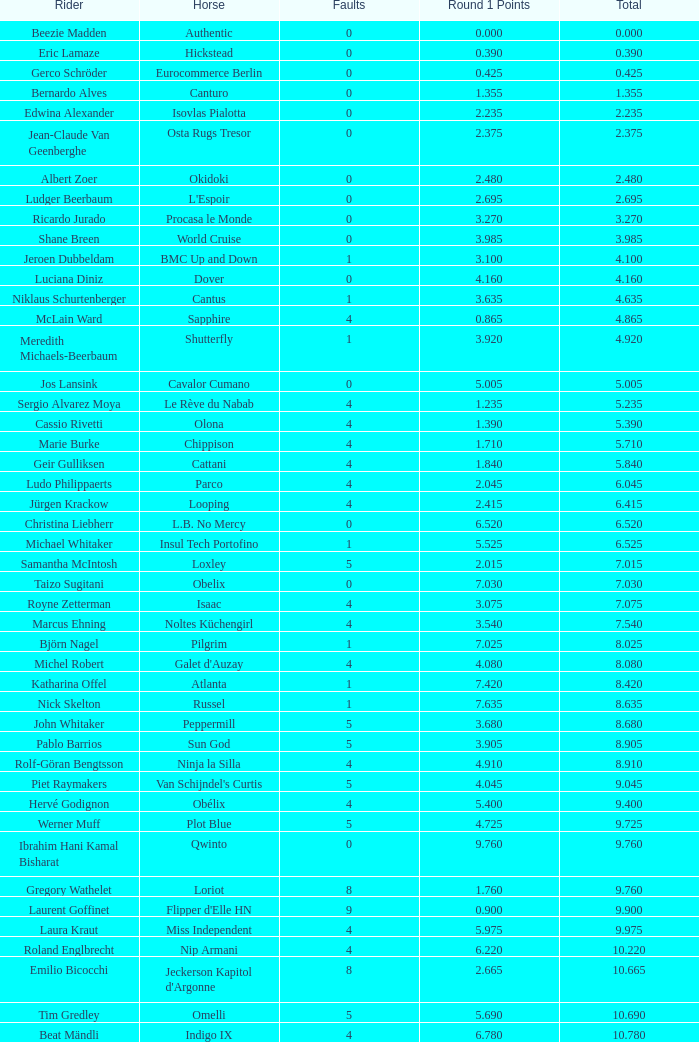Tell me the rider that had round 1 points of 7.465 and total more than 16.615 Manuel Fernandez Saro. 